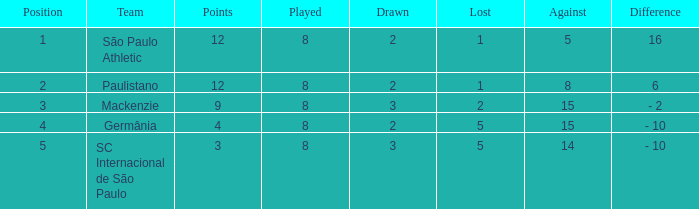What was the position with the total number less than 1? 0.0. 